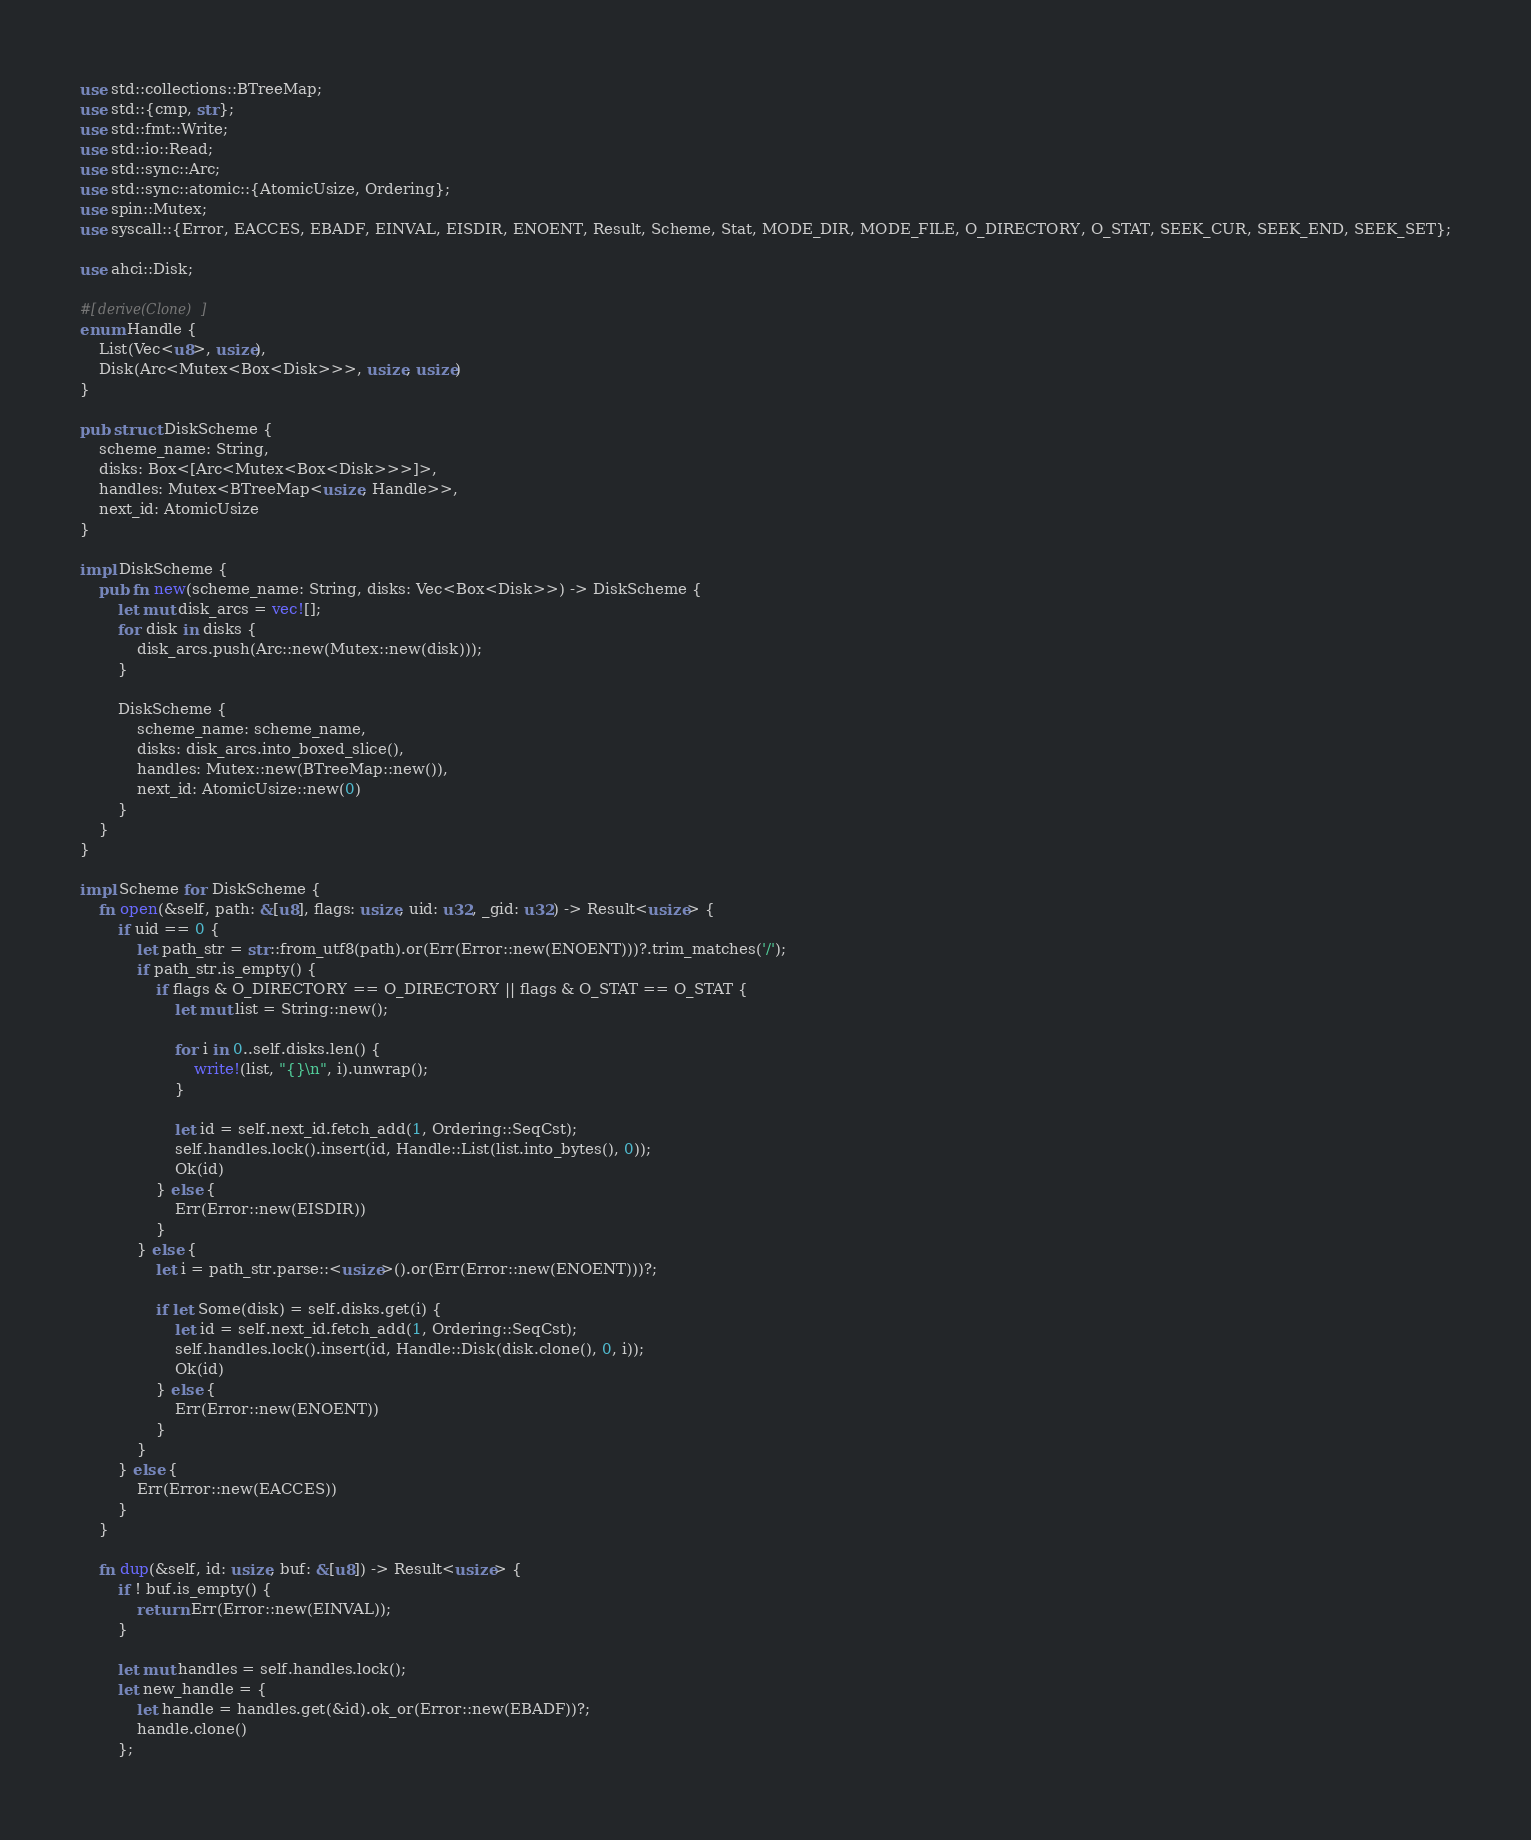Convert code to text. <code><loc_0><loc_0><loc_500><loc_500><_Rust_>use std::collections::BTreeMap;
use std::{cmp, str};
use std::fmt::Write;
use std::io::Read;
use std::sync::Arc;
use std::sync::atomic::{AtomicUsize, Ordering};
use spin::Mutex;
use syscall::{Error, EACCES, EBADF, EINVAL, EISDIR, ENOENT, Result, Scheme, Stat, MODE_DIR, MODE_FILE, O_DIRECTORY, O_STAT, SEEK_CUR, SEEK_END, SEEK_SET};

use ahci::Disk;

#[derive(Clone)]
enum Handle {
    List(Vec<u8>, usize),
    Disk(Arc<Mutex<Box<Disk>>>, usize, usize)
}

pub struct DiskScheme {
    scheme_name: String,
    disks: Box<[Arc<Mutex<Box<Disk>>>]>,
    handles: Mutex<BTreeMap<usize, Handle>>,
    next_id: AtomicUsize
}

impl DiskScheme {
    pub fn new(scheme_name: String, disks: Vec<Box<Disk>>) -> DiskScheme {
        let mut disk_arcs = vec![];
        for disk in disks {
            disk_arcs.push(Arc::new(Mutex::new(disk)));
        }

        DiskScheme {
            scheme_name: scheme_name,
            disks: disk_arcs.into_boxed_slice(),
            handles: Mutex::new(BTreeMap::new()),
            next_id: AtomicUsize::new(0)
        }
    }
}

impl Scheme for DiskScheme {
    fn open(&self, path: &[u8], flags: usize, uid: u32, _gid: u32) -> Result<usize> {
        if uid == 0 {
            let path_str = str::from_utf8(path).or(Err(Error::new(ENOENT)))?.trim_matches('/');
            if path_str.is_empty() {
                if flags & O_DIRECTORY == O_DIRECTORY || flags & O_STAT == O_STAT {
                    let mut list = String::new();

                    for i in 0..self.disks.len() {
                        write!(list, "{}\n", i).unwrap();
                    }

                    let id = self.next_id.fetch_add(1, Ordering::SeqCst);
                    self.handles.lock().insert(id, Handle::List(list.into_bytes(), 0));
                    Ok(id)
                } else {
                    Err(Error::new(EISDIR))
                }
            } else {
                let i = path_str.parse::<usize>().or(Err(Error::new(ENOENT)))?;

                if let Some(disk) = self.disks.get(i) {
                    let id = self.next_id.fetch_add(1, Ordering::SeqCst);
                    self.handles.lock().insert(id, Handle::Disk(disk.clone(), 0, i));
                    Ok(id)
                } else {
                    Err(Error::new(ENOENT))
                }
            }
        } else {
            Err(Error::new(EACCES))
        }
    }

    fn dup(&self, id: usize, buf: &[u8]) -> Result<usize> {
        if ! buf.is_empty() {
            return Err(Error::new(EINVAL));
        }

        let mut handles = self.handles.lock();
        let new_handle = {
            let handle = handles.get(&id).ok_or(Error::new(EBADF))?;
            handle.clone()
        };
</code> 